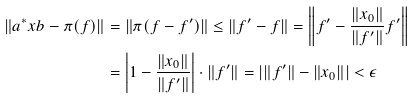Convert formula to latex. <formula><loc_0><loc_0><loc_500><loc_500>\| a ^ { * } x b - \pi ( f ) \| & = \| \pi ( f - f ^ { \prime } ) \| \leq \| f ^ { \prime } - f \| = \left \| f ^ { \prime } - \frac { \| x _ { 0 } \| } { \| f ^ { \prime } \| } f ^ { \prime } \right \| \\ & = \left | 1 - \frac { \| x _ { 0 } \| } { \| f ^ { \prime } \| } \right | \cdot \| f ^ { \prime } \| = \left | \| f ^ { \prime } \| - \| x _ { 0 } \| \right | < \epsilon</formula> 